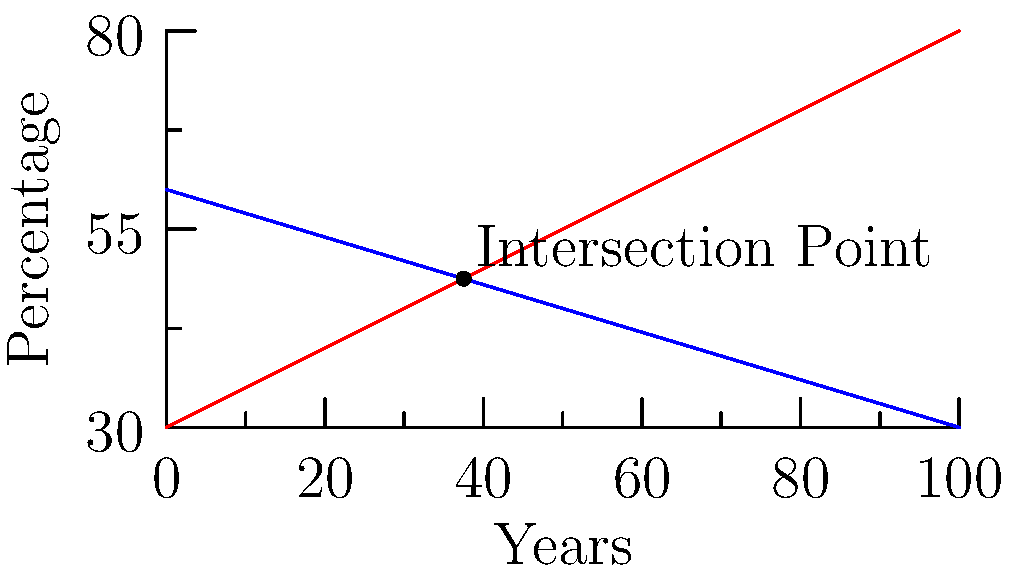In a minority neighborhood, two social factors are being tracked over time: employment rate and crime rate. The employment rate is increasing by 0.5% per year, starting at 30% in year 0. The crime rate is decreasing by 0.3% per year, starting at 60% in year 0. After how many years will these two rates intersect, and what will be the percentage at that point? Let's approach this step-by-step:

1) First, we need to write equations for both lines:
   Employment rate: $y = 0.5x + 30$
   Crime rate: $y = -0.3x + 60$

2) To find the intersection point, we set these equations equal to each other:
   $0.5x + 30 = -0.3x + 60$

3) Now, we solve for x:
   $0.5x + 0.3x = 60 - 30$
   $0.8x = 30$
   $x = 30 / 0.8 = 37.5$

4) This means the lines intersect after 37.5 years.

5) To find the percentage at this point, we can plug x = 37.5 into either equation:
   $y = 0.5(37.5) + 30 = 18.75 + 30 = 48.75$

Therefore, the employment rate and crime rate will both be 48.75% after 37.5 years.
Answer: 37.5 years; 48.75% 